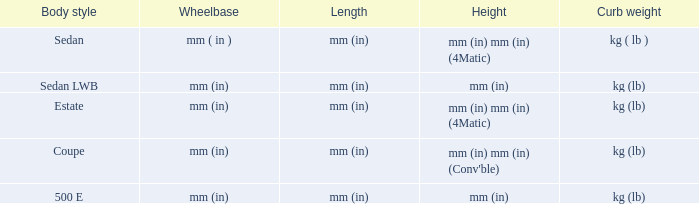Could you parse the entire table as a dict? {'header': ['Body style', 'Wheelbase', 'Length', 'Height', 'Curb weight'], 'rows': [['Sedan', 'mm ( in )', 'mm (in)', 'mm (in) mm (in) (4Matic)', 'kg ( lb )'], ['Sedan LWB', 'mm (in)', 'mm (in)', 'mm (in)', 'kg (lb)'], ['Estate', 'mm (in)', 'mm (in)', 'mm (in) mm (in) (4Matic)', 'kg (lb)'], ['Coupe', 'mm (in)', 'mm (in)', "mm (in) mm (in) (Conv'ble)", 'kg (lb)'], ['500 E', 'mm (in)', 'mm (in)', 'mm (in)', 'kg (lb)']]} What's the length of the model with 500 E body style? Mm (in). 